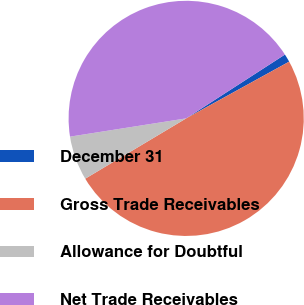<chart> <loc_0><loc_0><loc_500><loc_500><pie_chart><fcel>December 31<fcel>Gross Trade Receivables<fcel>Allowance for Doubtful<fcel>Net Trade Receivables<nl><fcel>1.12%<fcel>49.44%<fcel>6.09%<fcel>43.35%<nl></chart> 